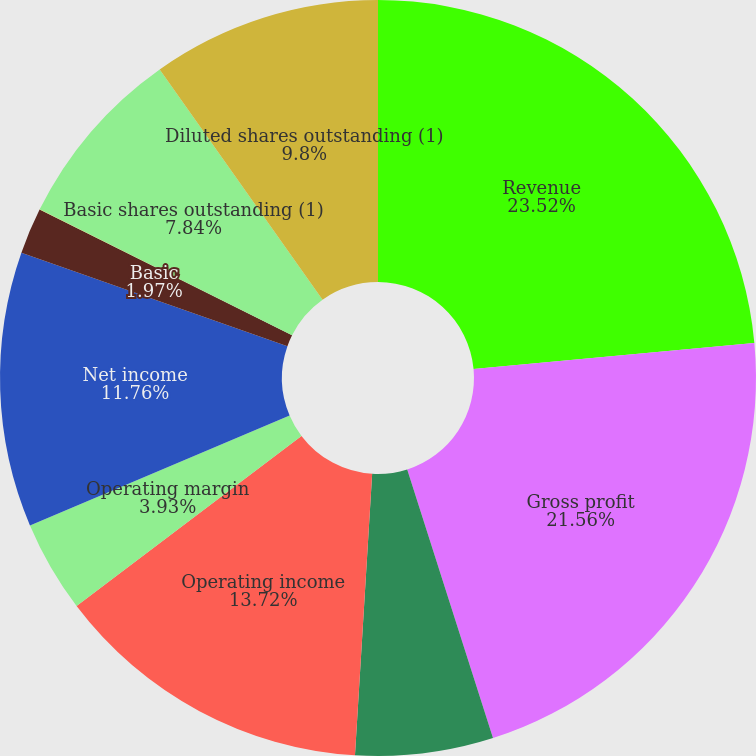Convert chart to OTSL. <chart><loc_0><loc_0><loc_500><loc_500><pie_chart><fcel>Revenue<fcel>Gross profit<fcel>Gross margin<fcel>Operating income<fcel>Operating margin<fcel>Net income<fcel>Basic<fcel>Diluted<fcel>Basic shares outstanding (1)<fcel>Diluted shares outstanding (1)<nl><fcel>23.52%<fcel>21.56%<fcel>5.89%<fcel>13.72%<fcel>3.93%<fcel>11.76%<fcel>1.97%<fcel>0.01%<fcel>7.84%<fcel>9.8%<nl></chart> 